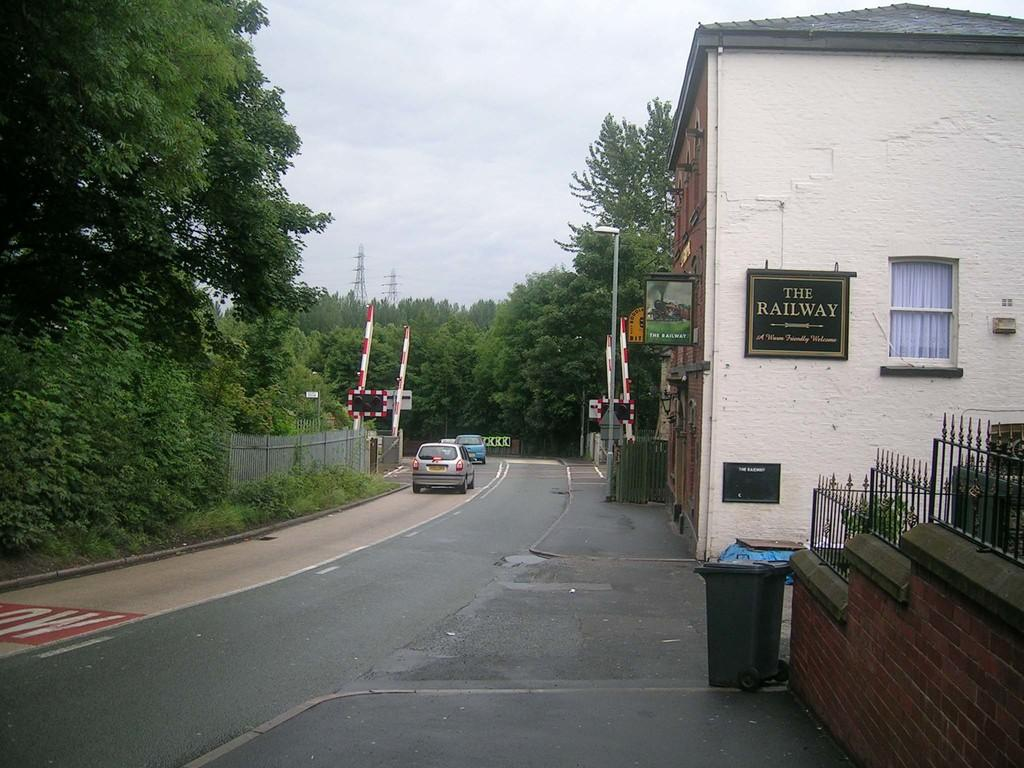<image>
Relay a brief, clear account of the picture shown. A warm friendly welcome from the Railway located off the street. 